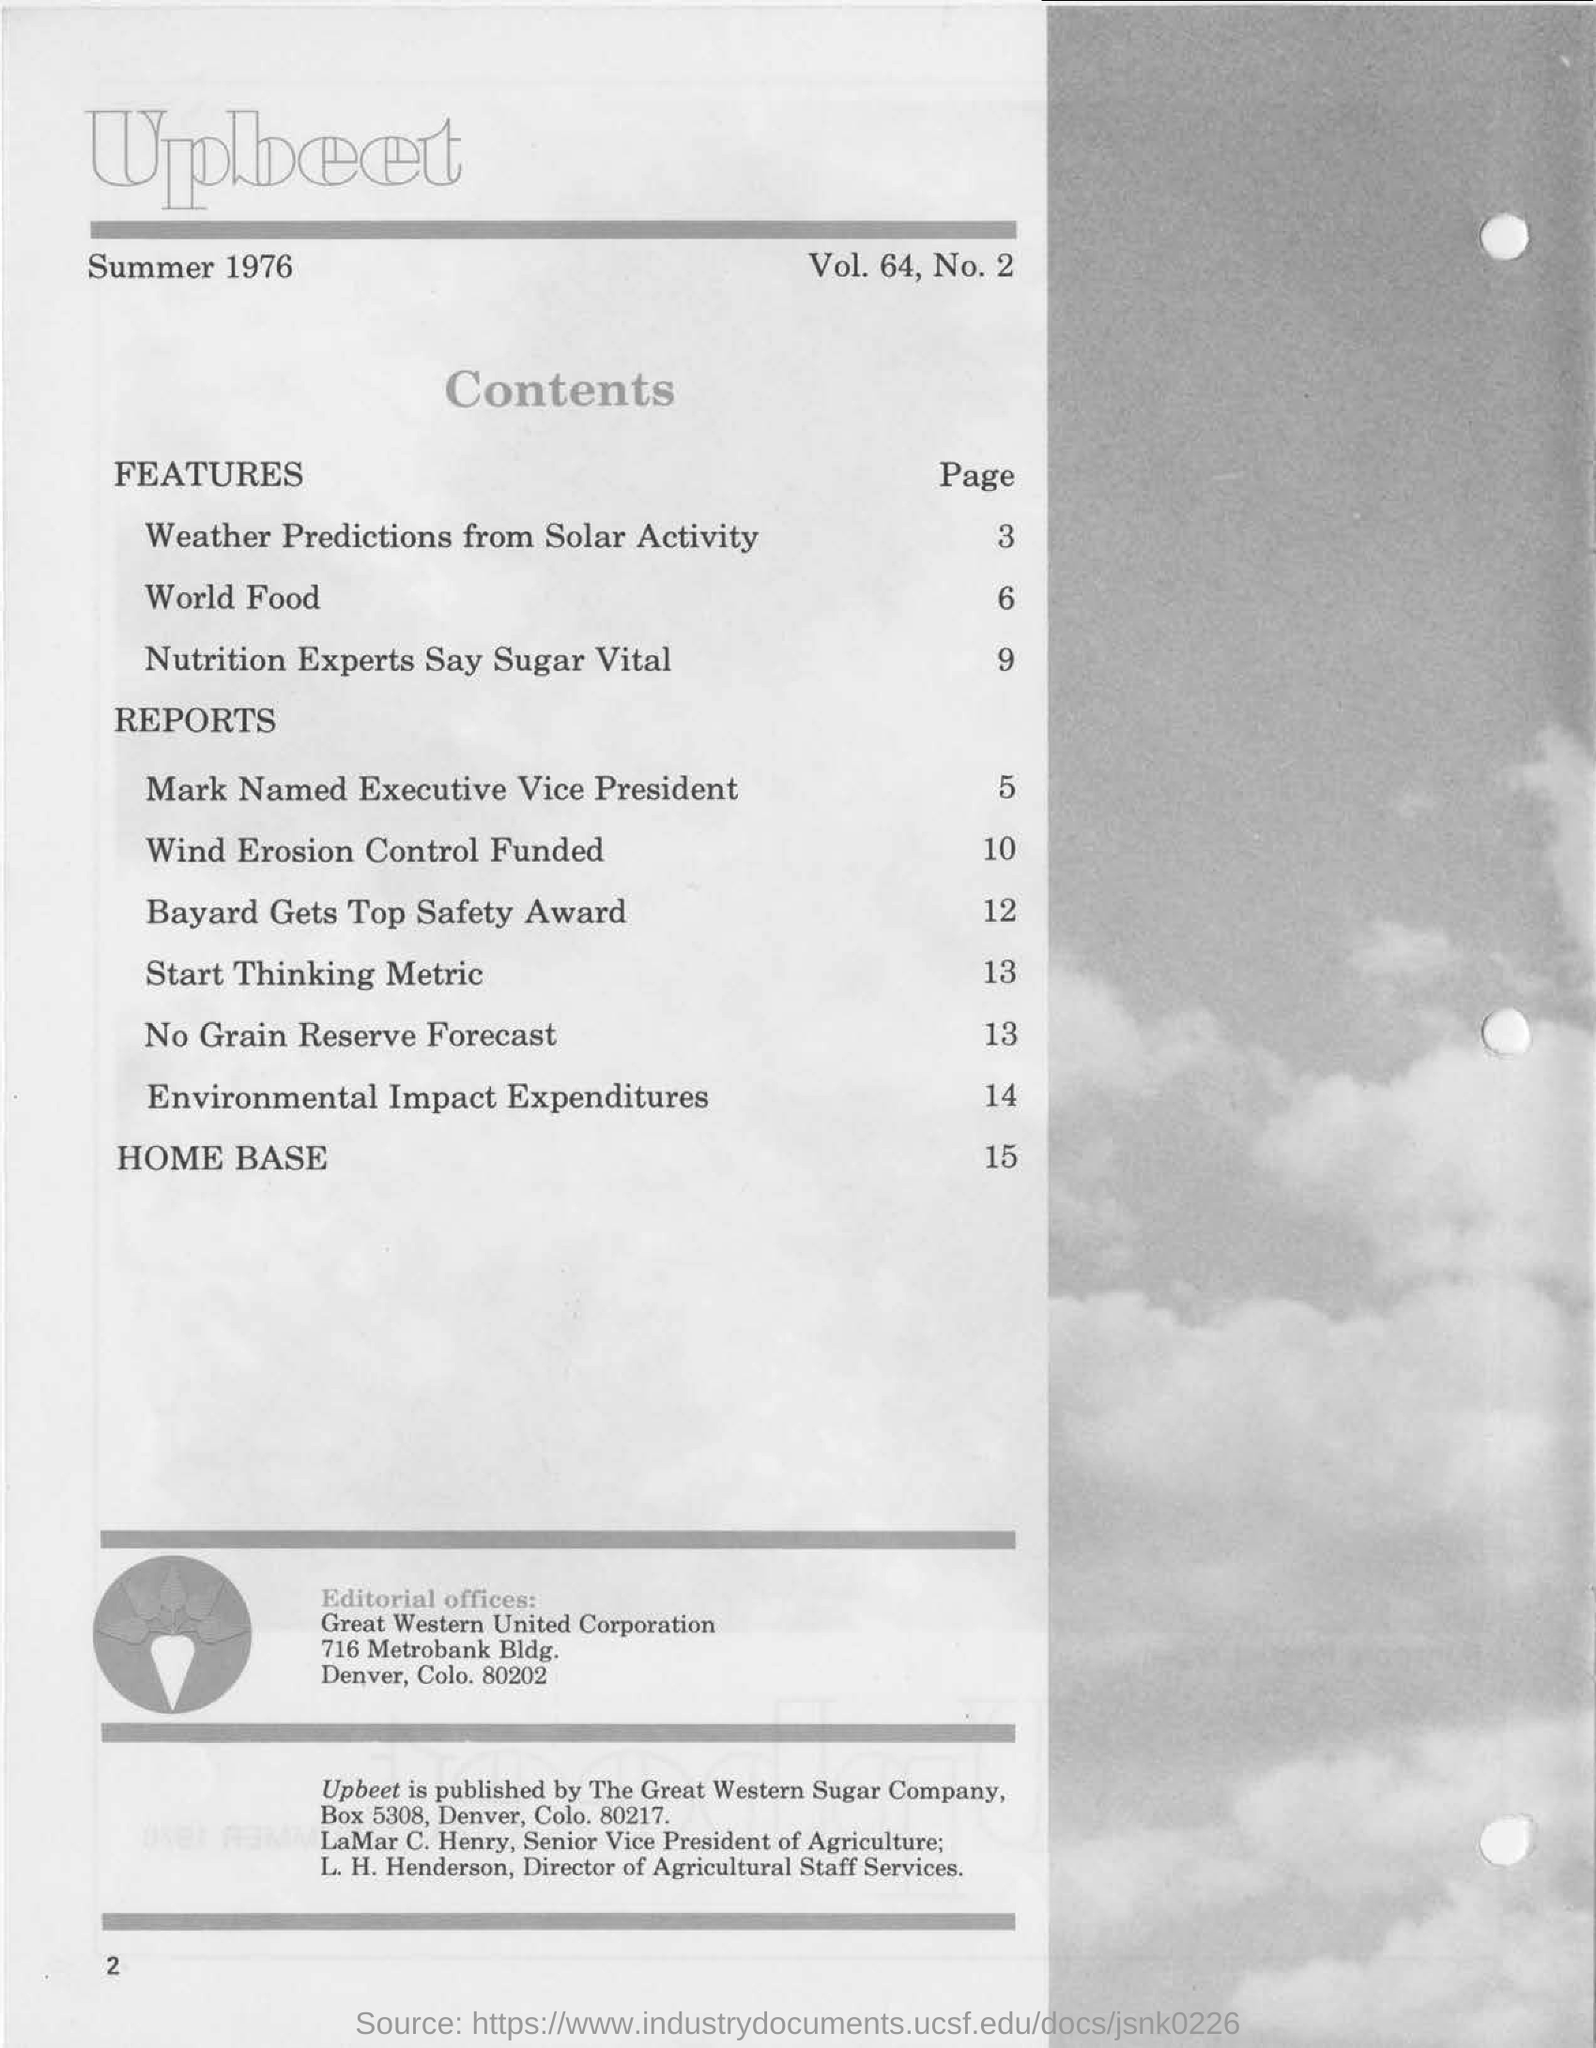Draw attention to some important aspects in this diagram. I am starting to think about the metric for page 13. Which page is 'world food' on?" is a question that is asking for information about where a particular topic or subject is located within a document or collection of documents. For example, if someone were asking this question, they might be trying to determine which page of a book, website, or other collection of documents contains information about world food. The page that provides weather predictions based on solar activity is page 3. 